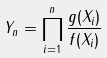Convert formula to latex. <formula><loc_0><loc_0><loc_500><loc_500>Y _ { n } = \prod _ { i = 1 } ^ { n } \frac { g ( X _ { i } ) } { f ( X _ { i } ) }</formula> 